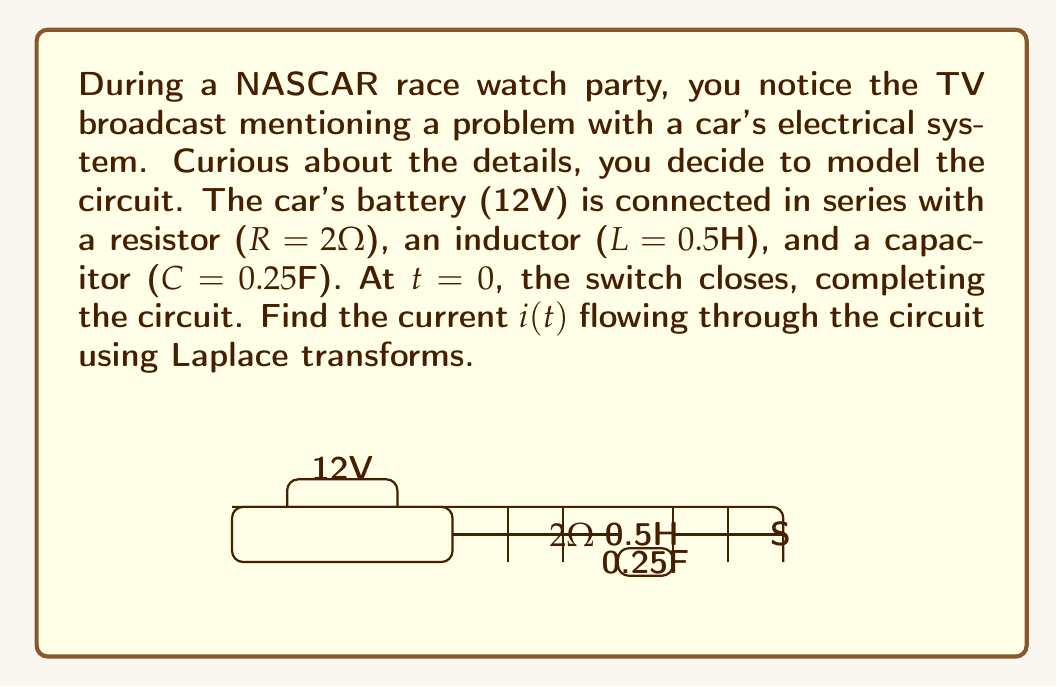Show me your answer to this math problem. To solve this problem using Laplace transforms, we'll follow these steps:

1) First, we need to write the differential equation for the circuit:

   $$L\frac{di}{dt} + Ri + \frac{1}{C}\int i dt = V$$

2) Taking the Laplace transform of both sides:

   $$L[sI(s) - i(0)] + RI(s) + \frac{1}{Cs}I(s) = \frac{V}{s}$$

   Where i(0) = 0 as the switch closes at t = 0.

3) Simplify:

   $$LsI(s) + RI(s) + \frac{1}{Cs}I(s) = \frac{V}{s}$$

4) Factor out I(s):

   $$I(s)(Ls + R + \frac{1}{Cs}) = \frac{V}{s}$$

5) Solve for I(s):

   $$I(s) = \frac{V}{s(Ls + R + \frac{1}{Cs})}$$

6) Substitute the given values:

   $$I(s) = \frac{12}{s(0.5s + 2 + \frac{1}{0.25s})} = \frac{12}{0.5s^2 + 2s + 4}$$

7) To find the inverse Laplace transform, we need to factor the denominator:

   $$0.5s^2 + 2s + 4 = 0.5(s^2 + 4s + 8) = 0.5(s + 2)^2$$

8) Now we can write I(s) as:

   $$I(s) = \frac{24}{(s + 2)^2}$$

9) The inverse Laplace transform of this is:

   $$i(t) = 24te^{-2t}$$

This is the current flowing through the circuit as a function of time.
Answer: $i(t) = 24te^{-2t}$ amperes 